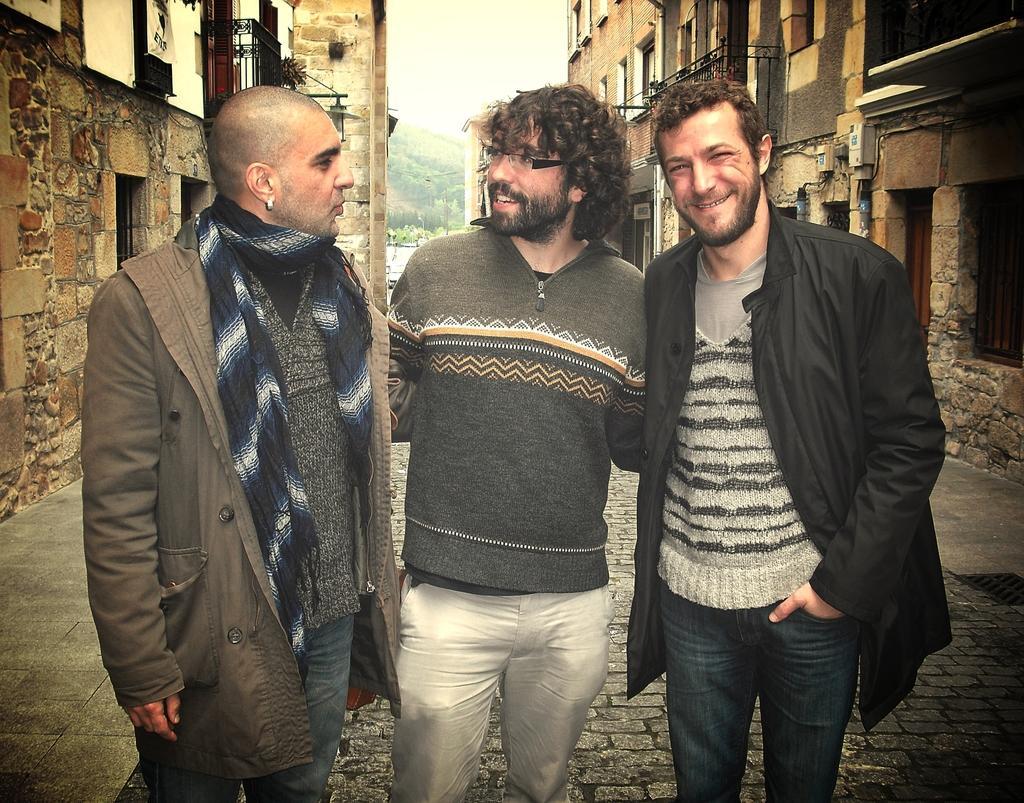How would you summarize this image in a sentence or two? In this image, there are three men standing, at the background there are some buildings and there is a sky. 